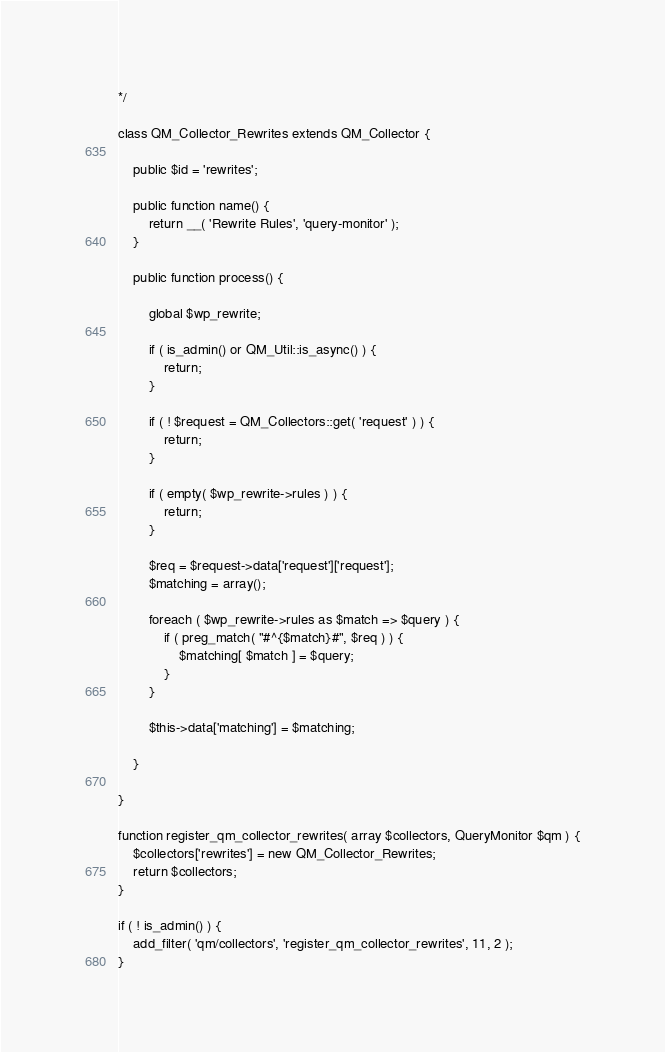<code> <loc_0><loc_0><loc_500><loc_500><_PHP_>
*/

class QM_Collector_Rewrites extends QM_Collector {

	public $id = 'rewrites';

	public function name() {
		return __( 'Rewrite Rules', 'query-monitor' );
	}

	public function process() {

		global $wp_rewrite;

		if ( is_admin() or QM_Util::is_async() ) {
			return;
		}

		if ( ! $request = QM_Collectors::get( 'request' ) ) {
			return;
		}

		if ( empty( $wp_rewrite->rules ) ) {
			return;
		}

		$req = $request->data['request']['request'];
		$matching = array();

		foreach ( $wp_rewrite->rules as $match => $query ) {
			if ( preg_match( "#^{$match}#", $req ) ) {
				$matching[ $match ] = $query;
			}
		}

		$this->data['matching'] = $matching;

	}

}

function register_qm_collector_rewrites( array $collectors, QueryMonitor $qm ) {
	$collectors['rewrites'] = new QM_Collector_Rewrites;
	return $collectors;
}

if ( ! is_admin() ) {
	add_filter( 'qm/collectors', 'register_qm_collector_rewrites', 11, 2 );
}
</code> 